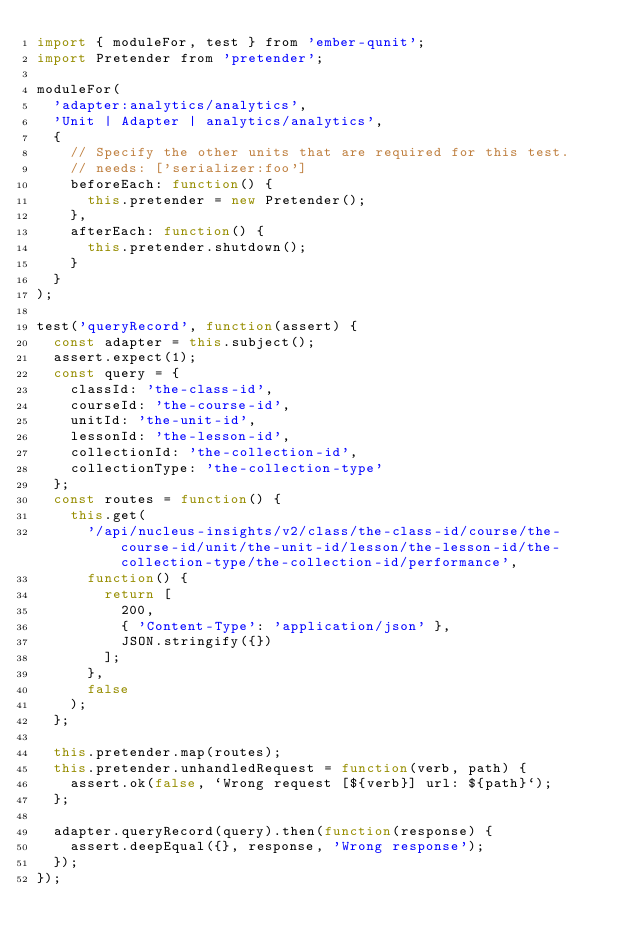<code> <loc_0><loc_0><loc_500><loc_500><_JavaScript_>import { moduleFor, test } from 'ember-qunit';
import Pretender from 'pretender';

moduleFor(
  'adapter:analytics/analytics',
  'Unit | Adapter | analytics/analytics',
  {
    // Specify the other units that are required for this test.
    // needs: ['serializer:foo']
    beforeEach: function() {
      this.pretender = new Pretender();
    },
    afterEach: function() {
      this.pretender.shutdown();
    }
  }
);

test('queryRecord', function(assert) {
  const adapter = this.subject();
  assert.expect(1);
  const query = {
    classId: 'the-class-id',
    courseId: 'the-course-id',
    unitId: 'the-unit-id',
    lessonId: 'the-lesson-id',
    collectionId: 'the-collection-id',
    collectionType: 'the-collection-type'
  };
  const routes = function() {
    this.get(
      '/api/nucleus-insights/v2/class/the-class-id/course/the-course-id/unit/the-unit-id/lesson/the-lesson-id/the-collection-type/the-collection-id/performance',
      function() {
        return [
          200,
          { 'Content-Type': 'application/json' },
          JSON.stringify({})
        ];
      },
      false
    );
  };

  this.pretender.map(routes);
  this.pretender.unhandledRequest = function(verb, path) {
    assert.ok(false, `Wrong request [${verb}] url: ${path}`);
  };

  adapter.queryRecord(query).then(function(response) {
    assert.deepEqual({}, response, 'Wrong response');
  });
});
</code> 